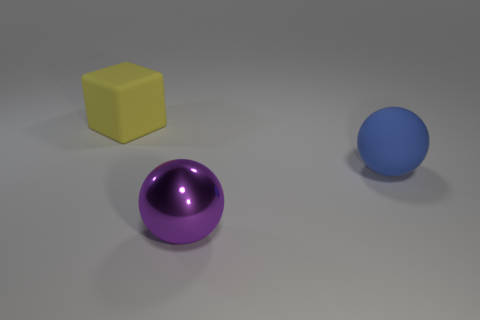What number of green rubber things are the same shape as the purple thing?
Provide a succinct answer. 0. What number of objects are either big blocks or large yellow matte cubes that are behind the shiny object?
Your response must be concise. 1. What is the purple thing made of?
Ensure brevity in your answer.  Metal. There is a large purple object that is the same shape as the large blue thing; what is its material?
Keep it short and to the point. Metal. There is a large matte object that is left of the big matte thing on the right side of the yellow rubber thing; what is its color?
Offer a terse response. Yellow. How many rubber objects are either big spheres or large purple balls?
Your answer should be compact. 1. Do the large cube and the purple sphere have the same material?
Offer a very short reply. No. What is the big sphere in front of the object to the right of the big metallic sphere made of?
Your answer should be compact. Metal. How many small things are either gray rubber spheres or matte cubes?
Your answer should be very brief. 0. What is the size of the yellow block?
Offer a very short reply. Large. 